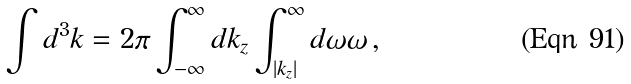Convert formula to latex. <formula><loc_0><loc_0><loc_500><loc_500>\int d ^ { 3 } k = 2 \pi \int ^ { \infty } _ { - \infty } d k _ { z } \int ^ { \infty } _ { | k _ { z } | } d \omega \omega \, ,</formula> 